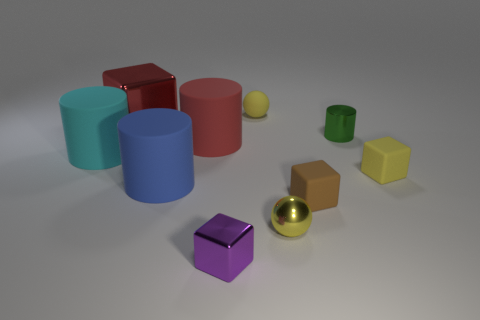Subtract 1 blocks. How many blocks are left? 3 Subtract all spheres. How many objects are left? 8 Add 4 tiny metallic cylinders. How many tiny metallic cylinders are left? 5 Add 5 cyan rubber objects. How many cyan rubber objects exist? 6 Subtract 0 gray cubes. How many objects are left? 10 Subtract all purple objects. Subtract all green metal cylinders. How many objects are left? 8 